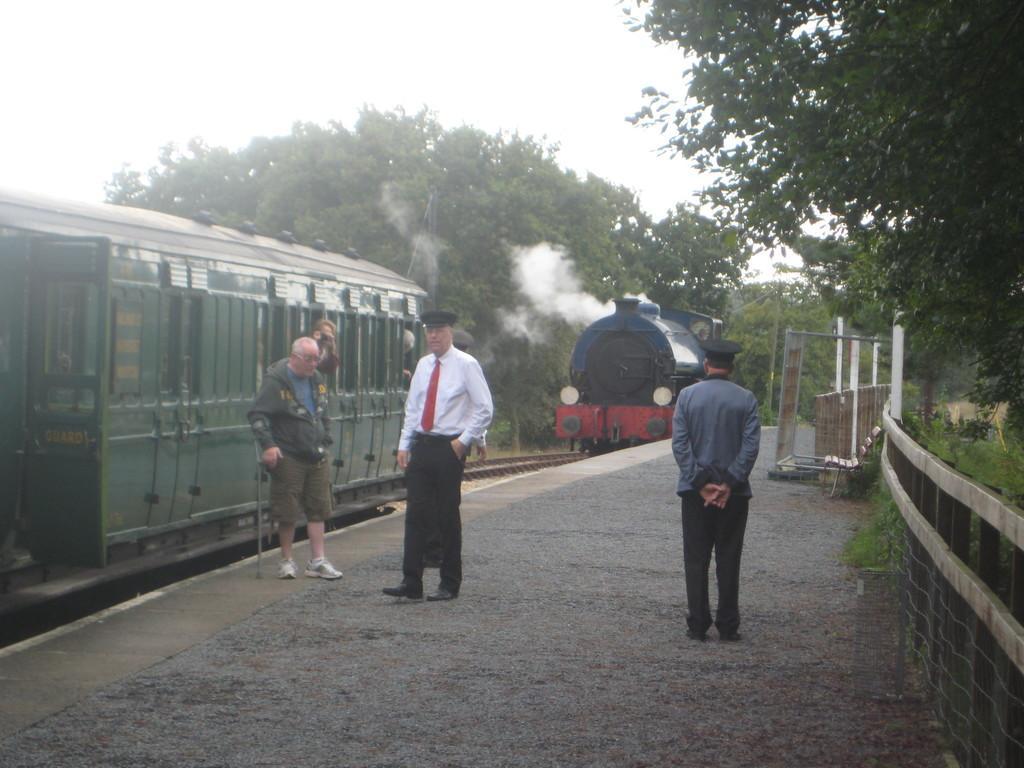In one or two sentences, can you explain what this image depicts? In the background we can see the sky, trees. In this picture we can see the train, engine, smoke, train track and the people. We can see the people on the platform. On the right side of the picture we can see railing, trees, bench, few objects and green grass. 